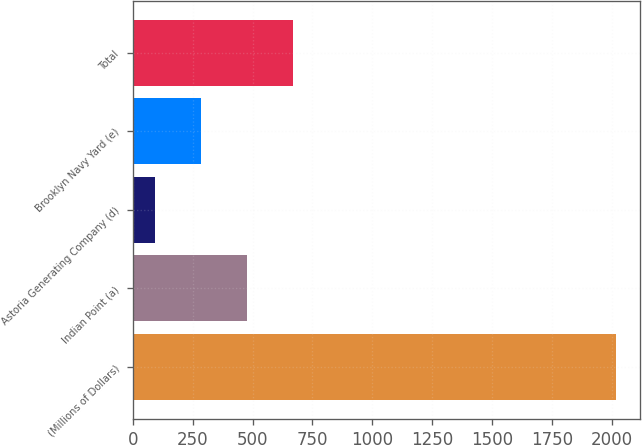Convert chart to OTSL. <chart><loc_0><loc_0><loc_500><loc_500><bar_chart><fcel>(Millions of Dollars)<fcel>Indian Point (a)<fcel>Astoria Generating Company (d)<fcel>Brooklyn Navy Yard (e)<fcel>Total<nl><fcel>2017<fcel>477<fcel>92<fcel>284.5<fcel>669.5<nl></chart> 